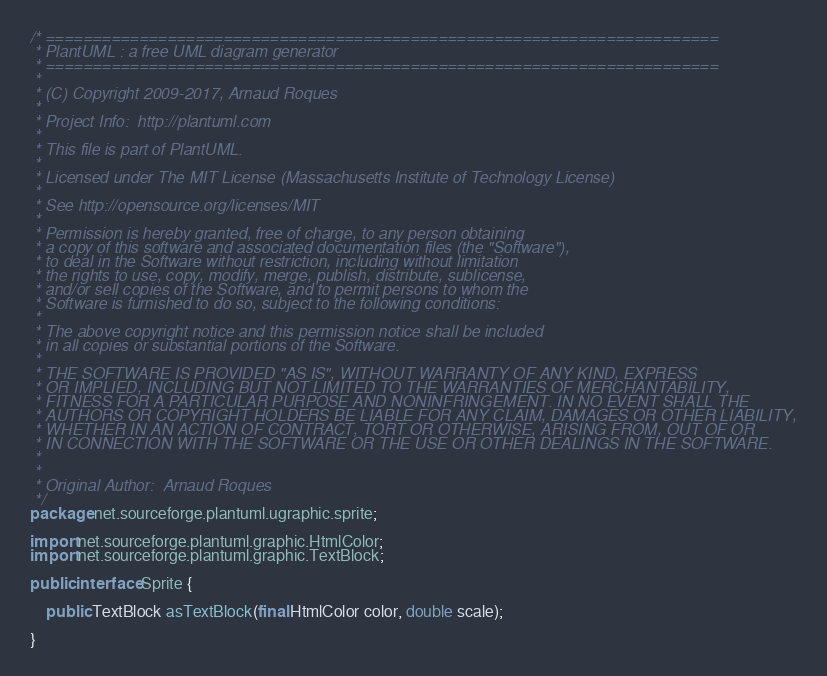<code> <loc_0><loc_0><loc_500><loc_500><_Java_>/* ========================================================================
 * PlantUML : a free UML diagram generator
 * ========================================================================
 *
 * (C) Copyright 2009-2017, Arnaud Roques
 *
 * Project Info:  http://plantuml.com
 * 
 * This file is part of PlantUML.
 *
 * Licensed under The MIT License (Massachusetts Institute of Technology License)
 * 
 * See http://opensource.org/licenses/MIT
 * 
 * Permission is hereby granted, free of charge, to any person obtaining
 * a copy of this software and associated documentation files (the "Software"),
 * to deal in the Software without restriction, including without limitation
 * the rights to use, copy, modify, merge, publish, distribute, sublicense,
 * and/or sell copies of the Software, and to permit persons to whom the
 * Software is furnished to do so, subject to the following conditions:
 * 
 * The above copyright notice and this permission notice shall be included
 * in all copies or substantial portions of the Software.
 * 
 * THE SOFTWARE IS PROVIDED "AS IS", WITHOUT WARRANTY OF ANY KIND, EXPRESS
 * OR IMPLIED, INCLUDING BUT NOT LIMITED TO THE WARRANTIES OF MERCHANTABILITY,
 * FITNESS FOR A PARTICULAR PURPOSE AND NONINFRINGEMENT. IN NO EVENT SHALL THE
 * AUTHORS OR COPYRIGHT HOLDERS BE LIABLE FOR ANY CLAIM, DAMAGES OR OTHER LIABILITY,
 * WHETHER IN AN ACTION OF CONTRACT, TORT OR OTHERWISE, ARISING FROM, OUT OF OR
 * IN CONNECTION WITH THE SOFTWARE OR THE USE OR OTHER DEALINGS IN THE SOFTWARE.
 * 
 *
 * Original Author:  Arnaud Roques
 */
package net.sourceforge.plantuml.ugraphic.sprite;

import net.sourceforge.plantuml.graphic.HtmlColor;
import net.sourceforge.plantuml.graphic.TextBlock;

public interface Sprite {
	
	public TextBlock asTextBlock(final HtmlColor color, double scale);

}
</code> 